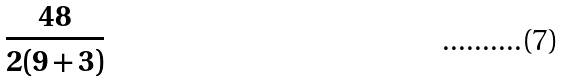<formula> <loc_0><loc_0><loc_500><loc_500>\frac { 4 8 } { 2 ( 9 + 3 ) }</formula> 